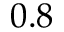<formula> <loc_0><loc_0><loc_500><loc_500>0 . 8</formula> 